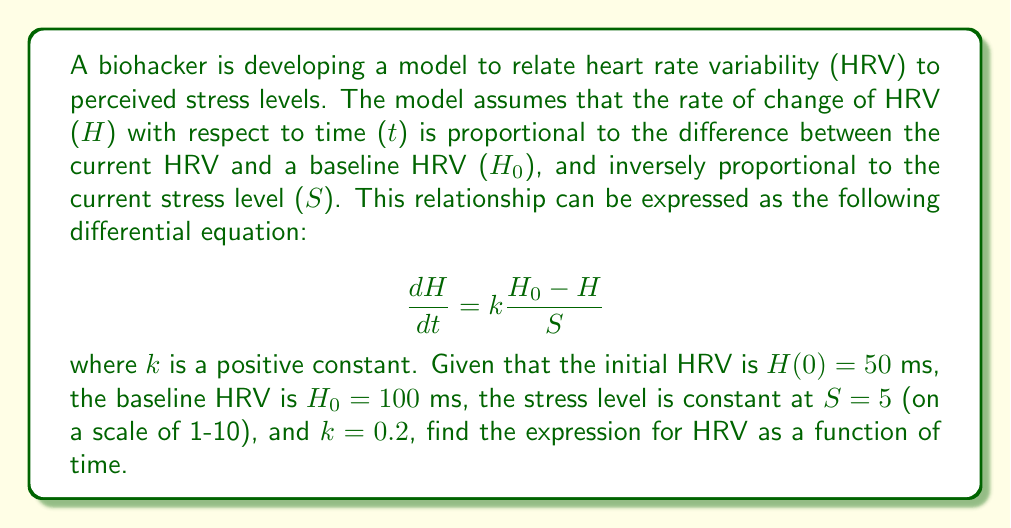What is the answer to this math problem? To solve this differential equation, we'll follow these steps:

1) First, rearrange the equation to separate variables:

   $$\frac{dH}{H_0 - H} = \frac{k}{S}dt$$

2) Integrate both sides:

   $$\int \frac{dH}{H_0 - H} = \int \frac{k}{S}dt$$

3) The left side integrates to $-\ln|H_0 - H|$, and the right side to $\frac{k}{S}t + C$:

   $$-\ln|H_0 - H| = \frac{k}{S}t + C$$

4) Solve for $H$:

   $$\ln|H_0 - H| = -\frac{k}{S}t - C$$
   $$|H_0 - H| = e^{-\frac{k}{S}t - C} = Ae^{-\frac{k}{S}t}$$, where $A = e^{-C}$
   $$H_0 - H = Ae^{-\frac{k}{S}t}$$
   $$H = H_0 - Ae^{-\frac{k}{S}t}$$

5) Use the initial condition $H(0) = 50$ to find $A$:

   $$50 = 100 - A$$
   $$A = 50$$

6) Substitute the values $k = 0.2$, $S = 5$, $H_0 = 100$, and $A = 50$:

   $$H = 100 - 50e^{-\frac{0.2}{5}t}$$

7) Simplify:

   $$H = 100 - 50e^{-0.04t}$$

This is the final expression for HRV as a function of time.
Answer: $H = 100 - 50e^{-0.04t}$ 